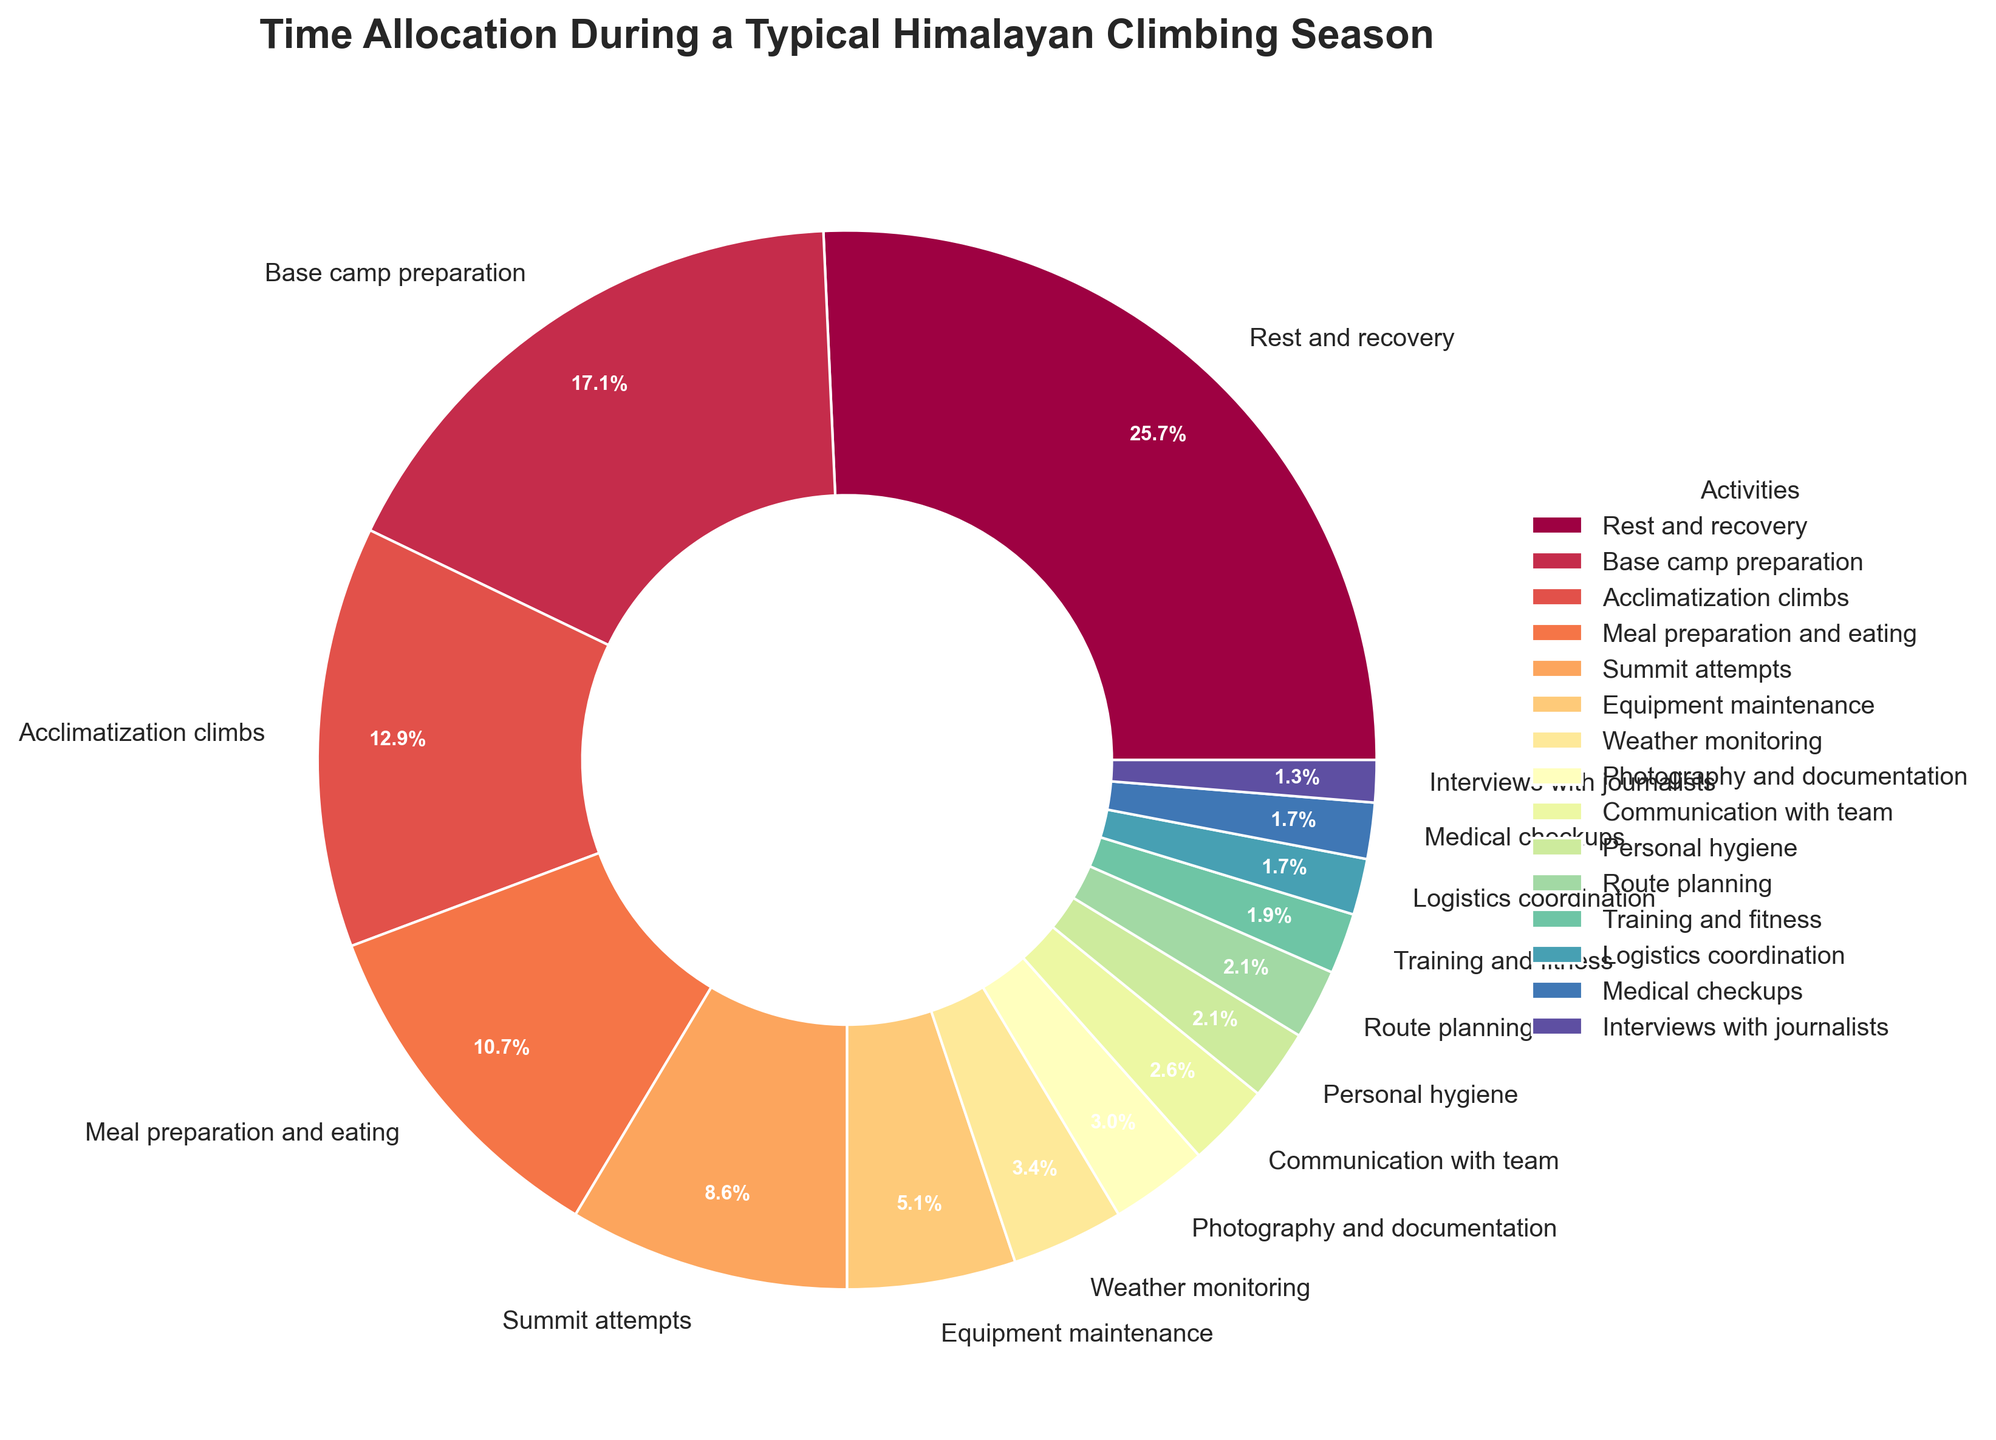How many hours are allocated to acclimatization climbs and summit attempts combined? To find the combined hours for acclimatization climbs and summit attempts, sum their respective hours from the data: 180 hours (acclimatization climbs) + 120 hours (summit attempts) = 300 hours
Answer: 300 hours Which activity takes up the largest portion of time? The activity with the largest portion of time is shown as the biggest slice of the pie chart. Rest and recovery is represented by the largest slice.
Answer: Rest and recovery What percentage of time is spent on equipment maintenance compared to medical checkups? To find the percentage comparison, use the values from the data. Equipment maintenance is 72 hours and medical checkups are 24 hours. The ratio is 72/24 = 3, so equipment maintenance takes up 300% of the time spent on medical checkups.
Answer: 300% Which activities take the least amount of time, and what are their combined percentages? The activities with the smallest slices represent the least amount of time. Interviews with journalists (18 hours), logistics coordination (24 hours), and medical checkups (24 hours) are the least. Sum the percentages of these three activities from the chart.
Answer: Interviews with journalists + logistics coordination + medical checkups = 2.6% + 3.4% + 3.4% = 9.4% What is the difference in percentage between base camp preparation and meal preparation and eating? Calculate the percentage for both activities: base camp preparation (240 hours) and meal preparation and eating (150 hours). Their percentages are approximately 21.8% and 13.6%. The difference is 21.8% - 13.6% = 8.2%
Answer: 8.2% How does the time spent on route planning compare to the time spent on personal hygiene? Route planning (30 hours) and personal hygiene (30 hours) both have the same duration and percentage allocation in the pie chart. Both slices are of equal size.
Answer: Equal Which three activities occupy the most time, and what percentage of the total time do they add up to? To find the three activities that occupy the most time, identify the largest slices: rest and recovery (360 hours), base camp preparation (240 hours), acclimatization climbs (180 hours). Sum their percentages: 32.7% + 21.8% + 16.4% = 70.9%
Answer: 70.9% What visual pattern do you observe about activities that have less than a 5% allocation? Activities less than 5% have smaller slices, making them visually narrower. These activities include equipment maintenance, weather monitoring, communication with team, medical checkups, route planning, interviews with journalists, photography and documentation, personal hygiene, logistics coordination, and training and fitness.
Answer: Narrower slices 